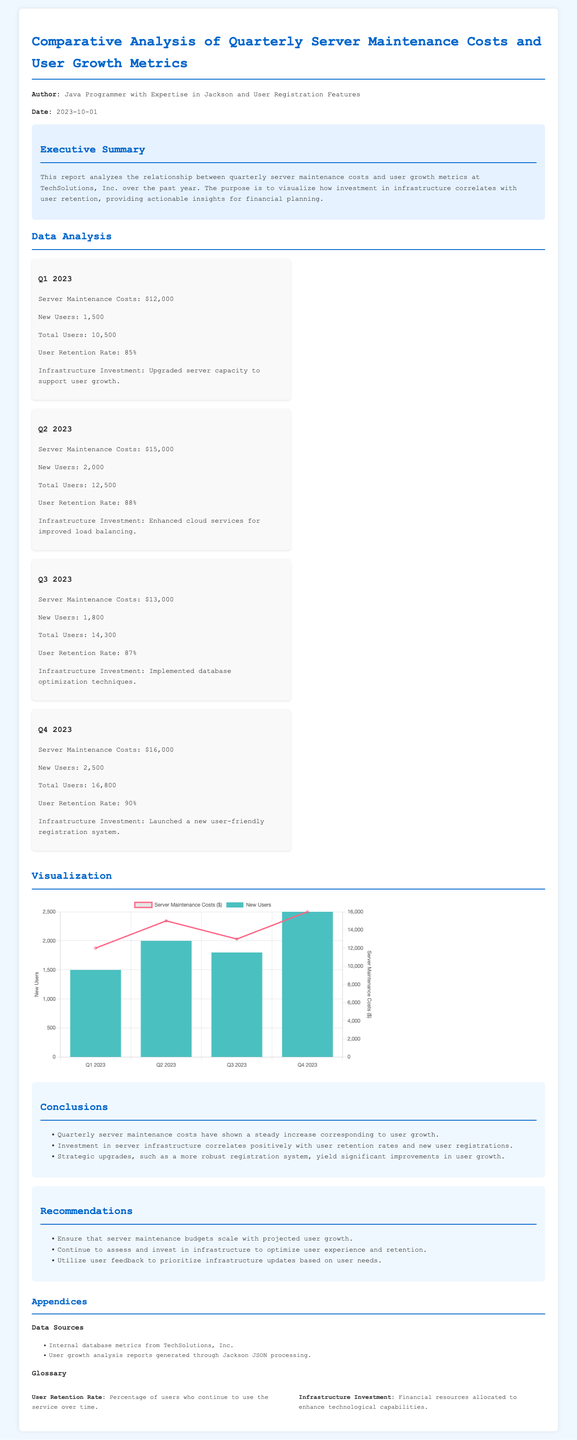What were the server maintenance costs in Q2 2023? The document states that the server maintenance costs in Q2 2023 were $15,000.
Answer: $15,000 What was the total number of users in Q4 2023? According to the data presented, the total number of users in Q4 2023 was 16,800.
Answer: 16,800 What infrastructure investment occurred in Q1 2023? The document mentions that an upgrade in server capacity was made to support user growth in Q1 2023.
Answer: Upgraded server capacity What was the user retention rate recorded in Q3 2023? The user retention rate for Q3 2023 indicated in the document is 87%.
Answer: 87% Which quarter had the highest new users? The analysis shows that Q4 2023 had the highest number of new users at 2,500.
Answer: Q4 2023 How does server maintenance impact user growth? The report concludes that investment in server infrastructure correlates positively with user retention rates and new user registrations.
Answer: Positively What was the user retention rate trend throughout the year? The document reflects that the user retention rate showed an increasing trend from Q1 to Q4 2023.
Answer: Increasing trend What primary conclusion is drawn about strategic upgrades? The analysis states that strategic upgrades, such as a new registration system, yield significant improvements in user growth.
Answer: Significant improvements What is the purpose of this financial report? The report aims to analyze the relationship between quarterly server maintenance costs and user growth metrics.
Answer: Analyze relationship 